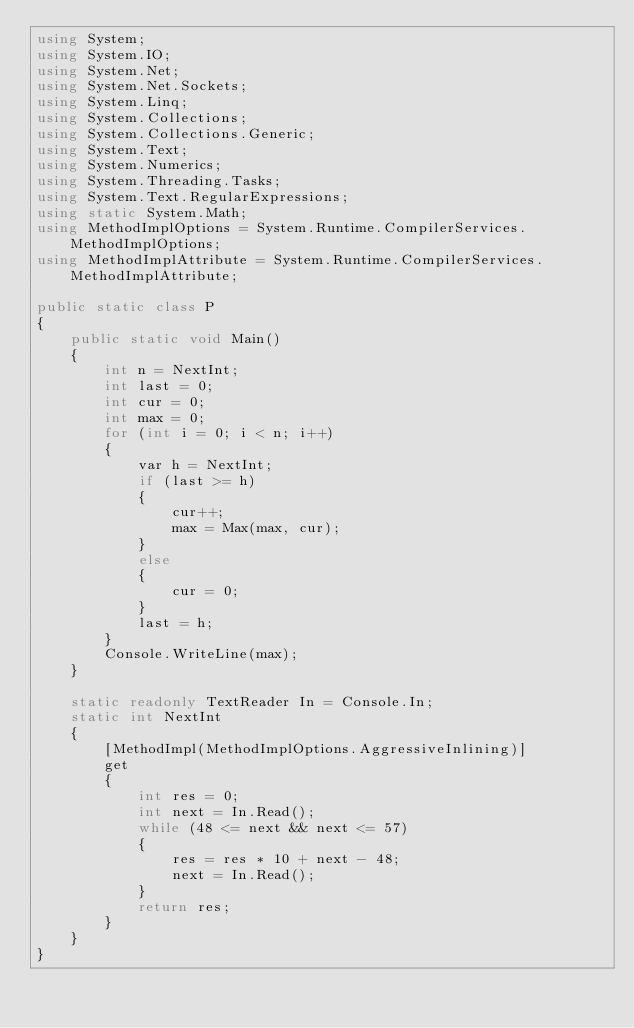Convert code to text. <code><loc_0><loc_0><loc_500><loc_500><_C#_>using System;
using System.IO;
using System.Net;
using System.Net.Sockets;
using System.Linq;
using System.Collections;
using System.Collections.Generic;
using System.Text;
using System.Numerics;
using System.Threading.Tasks;
using System.Text.RegularExpressions;
using static System.Math;
using MethodImplOptions = System.Runtime.CompilerServices.MethodImplOptions;
using MethodImplAttribute = System.Runtime.CompilerServices.MethodImplAttribute;

public static class P
{
    public static void Main()
    {
        int n = NextInt;
        int last = 0;
        int cur = 0;
        int max = 0;
        for (int i = 0; i < n; i++)
        {
            var h = NextInt;
            if (last >= h)
            {
                cur++;
                max = Max(max, cur);
            }
            else
            {
                cur = 0;
            }
            last = h;
        }
        Console.WriteLine(max);
    }

    static readonly TextReader In = Console.In;
    static int NextInt
    {
        [MethodImpl(MethodImplOptions.AggressiveInlining)]
        get
        {
            int res = 0;
            int next = In.Read();
            while (48 <= next && next <= 57)
            {
                res = res * 10 + next - 48;
                next = In.Read();
            }
            return res;
        }
    }
}
</code> 